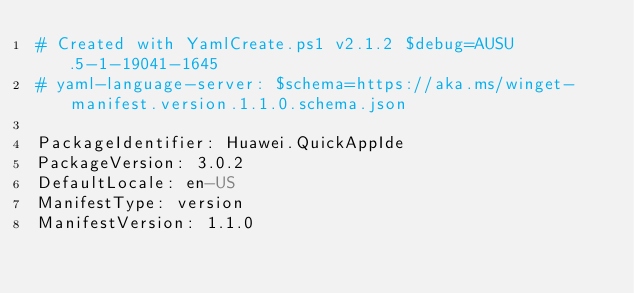<code> <loc_0><loc_0><loc_500><loc_500><_YAML_># Created with YamlCreate.ps1 v2.1.2 $debug=AUSU.5-1-19041-1645
# yaml-language-server: $schema=https://aka.ms/winget-manifest.version.1.1.0.schema.json

PackageIdentifier: Huawei.QuickAppIde
PackageVersion: 3.0.2
DefaultLocale: en-US
ManifestType: version
ManifestVersion: 1.1.0
</code> 